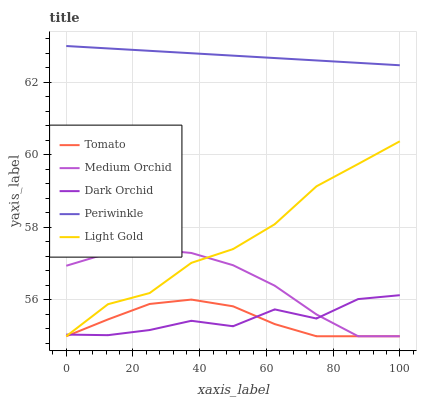Does Tomato have the minimum area under the curve?
Answer yes or no. Yes. Does Periwinkle have the maximum area under the curve?
Answer yes or no. Yes. Does Light Gold have the minimum area under the curve?
Answer yes or no. No. Does Light Gold have the maximum area under the curve?
Answer yes or no. No. Is Periwinkle the smoothest?
Answer yes or no. Yes. Is Dark Orchid the roughest?
Answer yes or no. Yes. Is Light Gold the smoothest?
Answer yes or no. No. Is Light Gold the roughest?
Answer yes or no. No. Does Tomato have the lowest value?
Answer yes or no. Yes. Does Periwinkle have the lowest value?
Answer yes or no. No. Does Periwinkle have the highest value?
Answer yes or no. Yes. Does Light Gold have the highest value?
Answer yes or no. No. Is Tomato less than Periwinkle?
Answer yes or no. Yes. Is Periwinkle greater than Medium Orchid?
Answer yes or no. Yes. Does Dark Orchid intersect Medium Orchid?
Answer yes or no. Yes. Is Dark Orchid less than Medium Orchid?
Answer yes or no. No. Is Dark Orchid greater than Medium Orchid?
Answer yes or no. No. Does Tomato intersect Periwinkle?
Answer yes or no. No. 